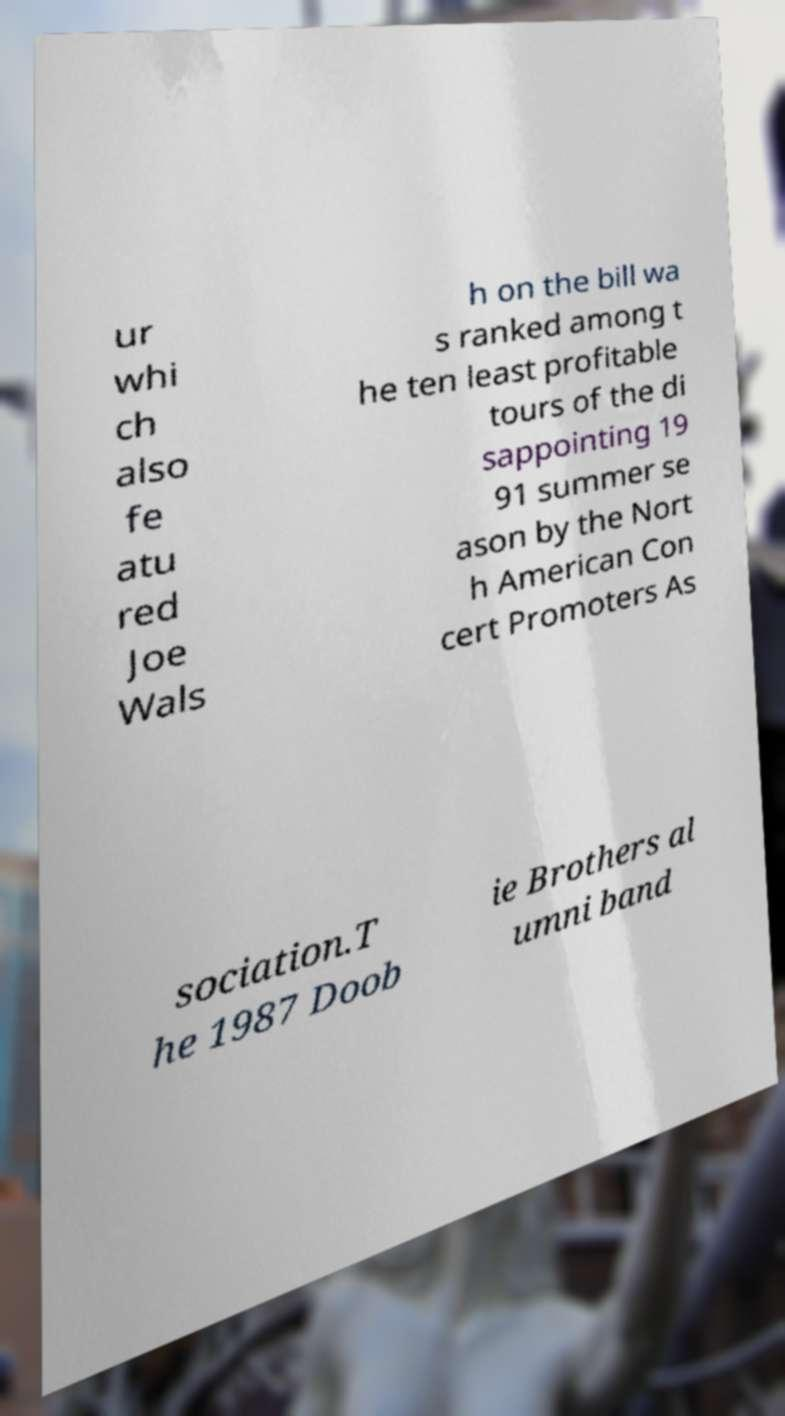Can you read and provide the text displayed in the image?This photo seems to have some interesting text. Can you extract and type it out for me? ur whi ch also fe atu red Joe Wals h on the bill wa s ranked among t he ten least profitable tours of the di sappointing 19 91 summer se ason by the Nort h American Con cert Promoters As sociation.T he 1987 Doob ie Brothers al umni band 